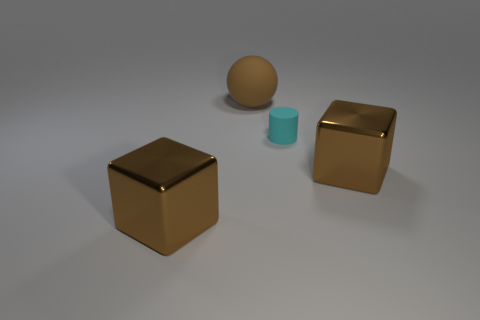Is there anything else that is the same size as the cyan thing?
Provide a short and direct response. No. Are there fewer large brown matte balls that are behind the big ball than large metallic things that are to the left of the small cylinder?
Your response must be concise. Yes. How many other things are there of the same material as the ball?
Your answer should be compact. 1. Is the material of the cyan thing the same as the ball?
Offer a terse response. Yes. What number of other objects are there of the same size as the cyan rubber thing?
Keep it short and to the point. 0. There is a brown shiny thing that is in front of the brown thing on the right side of the rubber sphere; what size is it?
Provide a short and direct response. Large. There is a big cube right of the cyan matte cylinder that is right of the large brown cube that is on the left side of the cyan cylinder; what color is it?
Keep it short and to the point. Brown. There is a thing that is left of the tiny cylinder and in front of the cyan cylinder; what size is it?
Provide a succinct answer. Large. What number of other objects are the same shape as the brown matte object?
Give a very brief answer. 0. How many blocks are cyan objects or large brown things?
Keep it short and to the point. 2. 